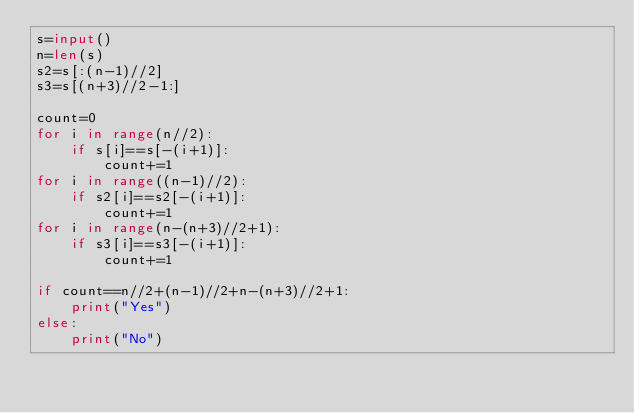Convert code to text. <code><loc_0><loc_0><loc_500><loc_500><_Python_>s=input()
n=len(s)
s2=s[:(n-1)//2]
s3=s[(n+3)//2-1:]

count=0
for i in range(n//2):
    if s[i]==s[-(i+1)]:
        count+=1
for i in range((n-1)//2):
    if s2[i]==s2[-(i+1)]:
        count+=1
for i in range(n-(n+3)//2+1):
    if s3[i]==s3[-(i+1)]:
        count+=1

if count==n//2+(n-1)//2+n-(n+3)//2+1:
    print("Yes")
else:
    print("No")
</code> 